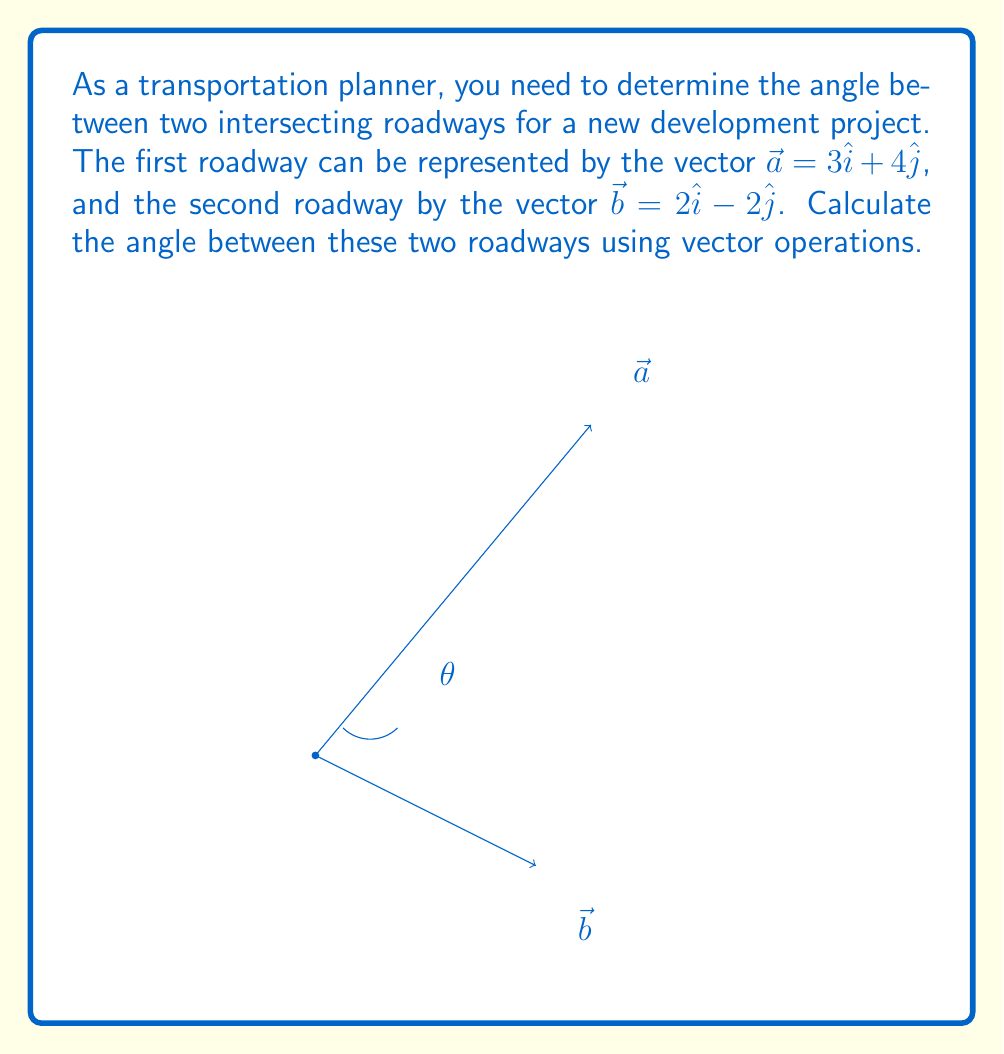Give your solution to this math problem. To find the angle between two vectors, we can use the dot product formula:

$$\cos \theta = \frac{\vec{a} \cdot \vec{b}}{|\vec{a}||\vec{b}|}$$

Step 1: Calculate the dot product $\vec{a} \cdot \vec{b}$
$$\vec{a} \cdot \vec{b} = (3)(2) + (4)(-2) = 6 - 8 = -2$$

Step 2: Calculate the magnitudes of $\vec{a}$ and $\vec{b}$
$$|\vec{a}| = \sqrt{3^2 + 4^2} = \sqrt{9 + 16} = \sqrt{25} = 5$$
$$|\vec{b}| = \sqrt{2^2 + (-2)^2} = \sqrt{4 + 4} = \sqrt{8} = 2\sqrt{2}$$

Step 3: Substitute into the dot product formula
$$\cos \theta = \frac{-2}{5(2\sqrt{2})} = -\frac{1}{5\sqrt{2}}$$

Step 4: Take the inverse cosine (arccos) of both sides
$$\theta = \arccos(-\frac{1}{5\sqrt{2}})$$

Step 5: Calculate the result (approximately)
$$\theta \approx 104.48°$$
Answer: $\theta = \arccos(-\frac{1}{5\sqrt{2}}) \approx 104.48°$ 